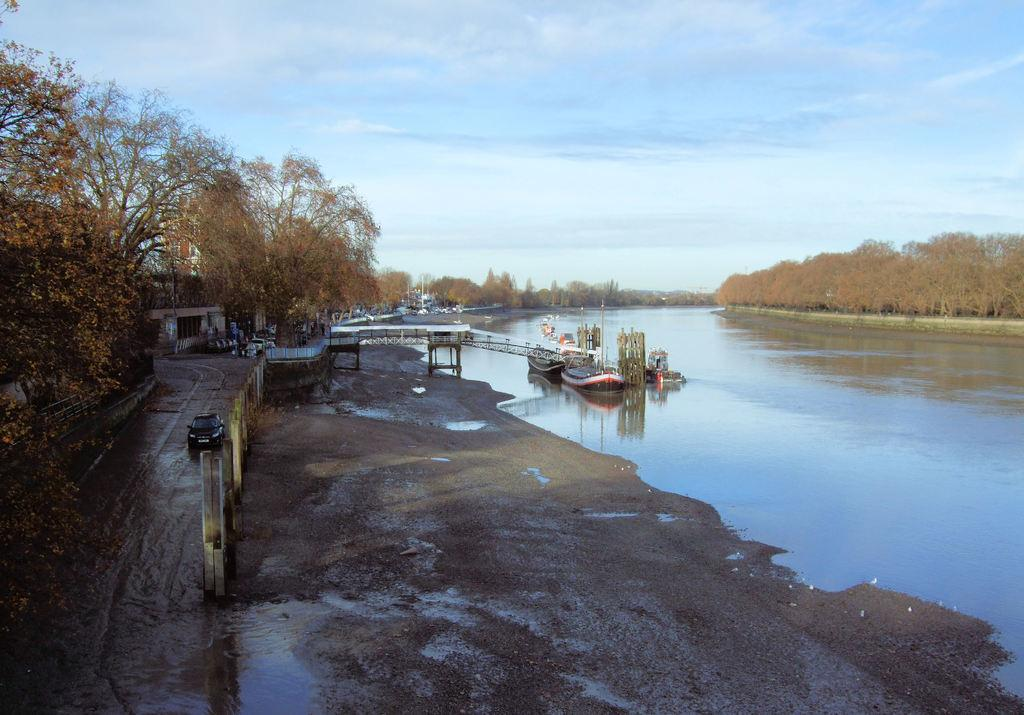What type of vehicle is on the road in the image? There is a vehicle on the road in the image, but the specific type is not mentioned. What other mode of transportation can be seen in the image? There are boats in the image. What natural element is visible in the image? Water is visible in the image. What type of vegetation is present in the image? There are trees in the image. What type of structure is visible in the image? There is a building in the image. How would you describe the weather in the image? The sky is cloudy in the image. What date is marked on the calendar in the image? There is no calendar present in the image. What type of education is being provided in the image? There is no indication of any educational activity in the image. Can you see a kite flying in the image? There is no kite visible in the image. 